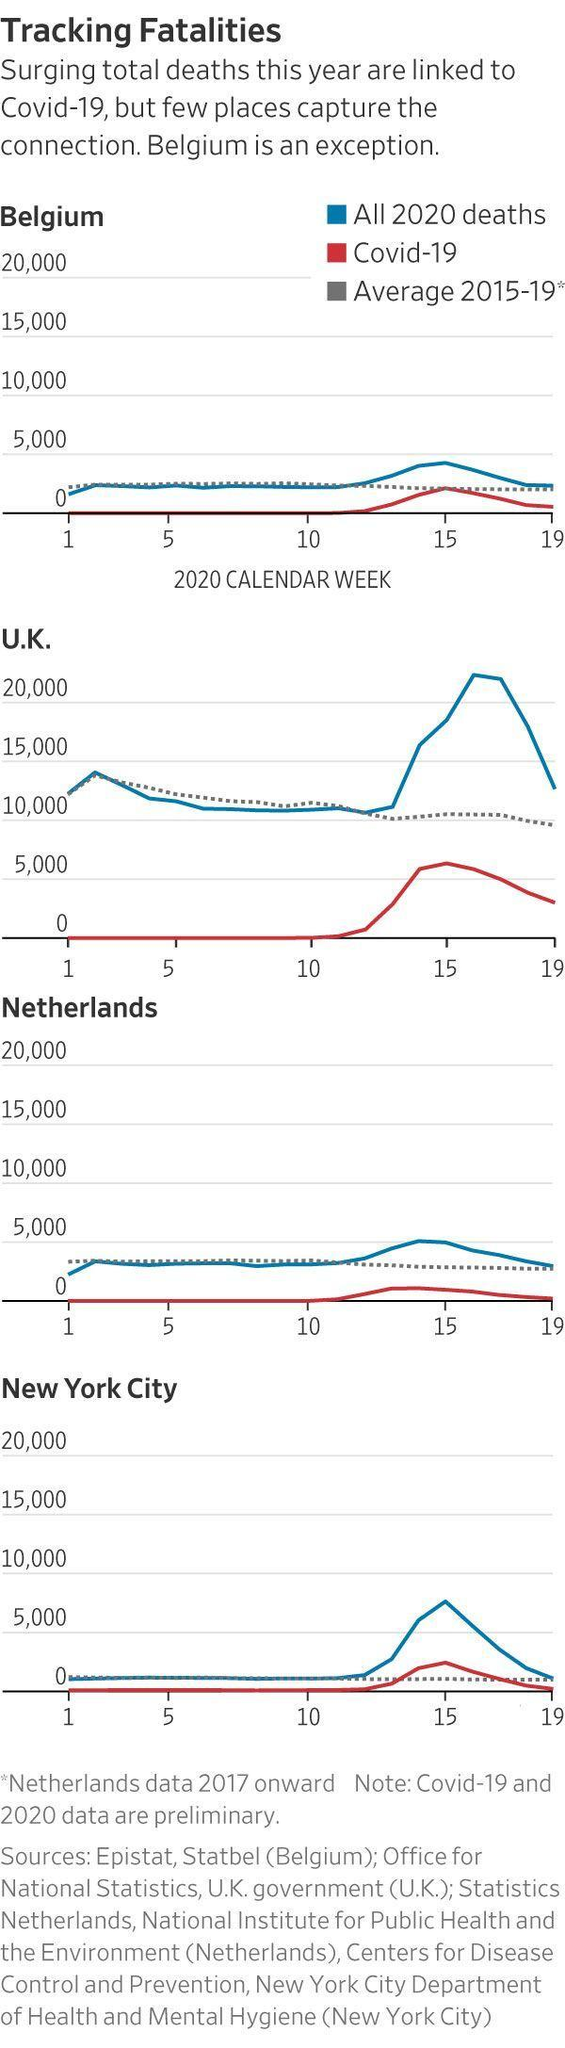What colour represents COVID-19 deaths, red or blue
Answer the question with a short phrase. red Which placed crossed the 20,000 death count U.K. What colour represents all 2020 deaths, red or blue blue In which week is the COVID-19 death at the same level as average 2015-19 death 15 